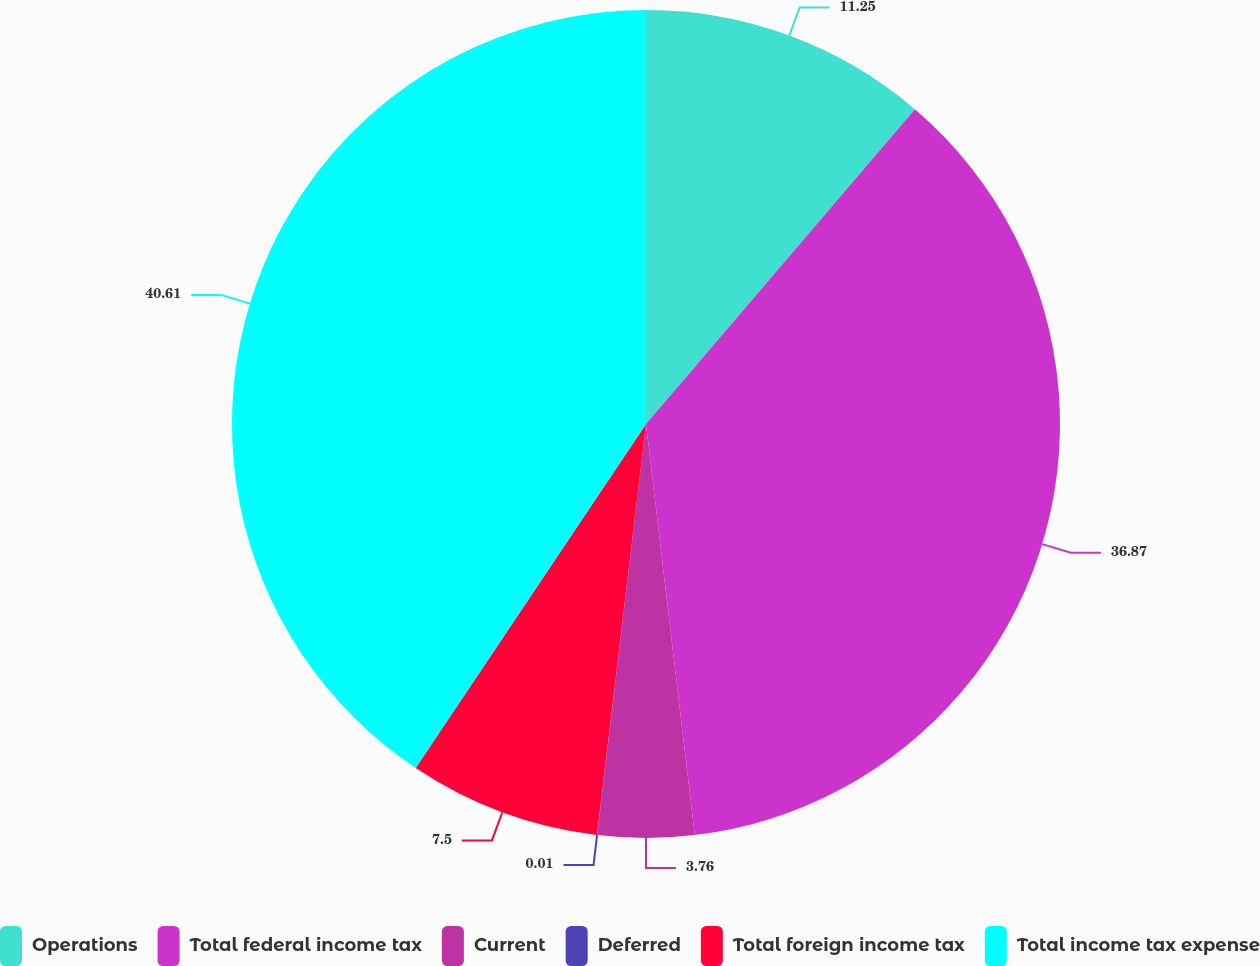Convert chart. <chart><loc_0><loc_0><loc_500><loc_500><pie_chart><fcel>Operations<fcel>Total federal income tax<fcel>Current<fcel>Deferred<fcel>Total foreign income tax<fcel>Total income tax expense<nl><fcel>11.25%<fcel>36.87%<fcel>3.76%<fcel>0.01%<fcel>7.5%<fcel>40.61%<nl></chart> 